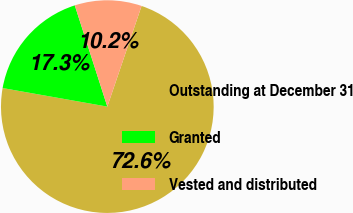Convert chart to OTSL. <chart><loc_0><loc_0><loc_500><loc_500><pie_chart><fcel>Outstanding at December 31<fcel>Granted<fcel>Vested and distributed<nl><fcel>72.58%<fcel>17.26%<fcel>10.17%<nl></chart> 